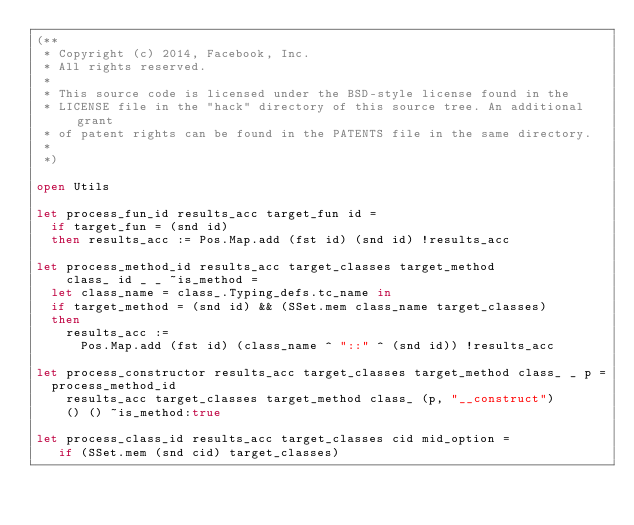<code> <loc_0><loc_0><loc_500><loc_500><_OCaml_>(**
 * Copyright (c) 2014, Facebook, Inc.
 * All rights reserved.
 *
 * This source code is licensed under the BSD-style license found in the
 * LICENSE file in the "hack" directory of this source tree. An additional grant
 * of patent rights can be found in the PATENTS file in the same directory.
 *
 *)

open Utils

let process_fun_id results_acc target_fun id =
  if target_fun = (snd id)
  then results_acc := Pos.Map.add (fst id) (snd id) !results_acc

let process_method_id results_acc target_classes target_method
    class_ id _ _ ~is_method =
  let class_name = class_.Typing_defs.tc_name in
  if target_method = (snd id) && (SSet.mem class_name target_classes)
  then
    results_acc :=
      Pos.Map.add (fst id) (class_name ^ "::" ^ (snd id)) !results_acc

let process_constructor results_acc target_classes target_method class_ _ p =
  process_method_id
    results_acc target_classes target_method class_ (p, "__construct")
    () () ~is_method:true

let process_class_id results_acc target_classes cid mid_option =
   if (SSet.mem (snd cid) target_classes)</code> 